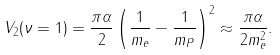<formula> <loc_0><loc_0><loc_500><loc_500>V _ { 2 } ( \nu = 1 ) = \frac { \pi \alpha } { 2 } \left ( \frac { 1 } { m _ { e } } - \frac { 1 } { m _ { P } } \right ) ^ { 2 } \approx \frac { \pi \alpha } { 2 m _ { e } ^ { 2 } } .</formula> 